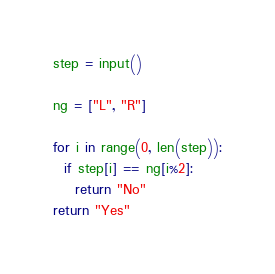<code> <loc_0><loc_0><loc_500><loc_500><_Python_>step = input()

ng = ["L", "R"]

for i in range(0, len(step)):
  if step[i] == ng[i%2]:
    return "No"
return "Yes"
</code> 